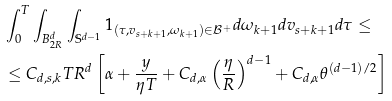Convert formula to latex. <formula><loc_0><loc_0><loc_500><loc_500>& \int _ { 0 } ^ { T } \int _ { B _ { 2 R } ^ { d } } \int _ { \mathbb { S } ^ { d - 1 } } 1 _ { ( \tau , v _ { s + k + 1 } , \omega _ { k + 1 } ) \in \mathcal { B } ^ { + } } d \omega _ { k + 1 } d v _ { s + k + 1 } d \tau \leq \\ & \leq C _ { d , s , k } T R ^ { d } \left [ \alpha + \frac { y } { \eta T } + C _ { d , \alpha } \left ( \frac { \eta } { R } \right ) ^ { d - 1 } + C _ { d , \alpha } \theta ^ { ( d - 1 ) / 2 } \right ]</formula> 